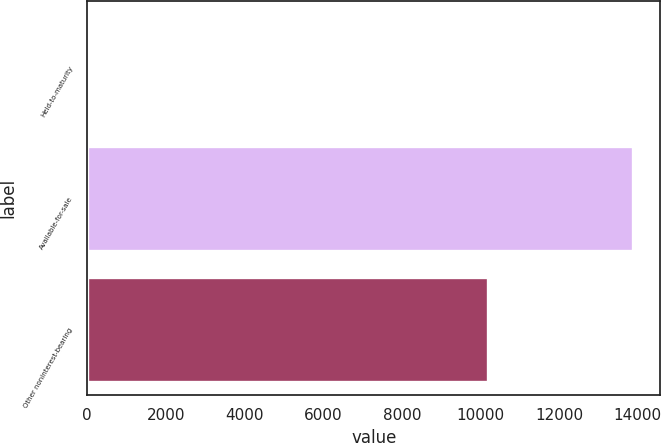<chart> <loc_0><loc_0><loc_500><loc_500><bar_chart><fcel>Held-to-maturity<fcel>Available-for-sale<fcel>Other noninterest-bearing<nl><fcel>81<fcel>13881<fcel>10182<nl></chart> 